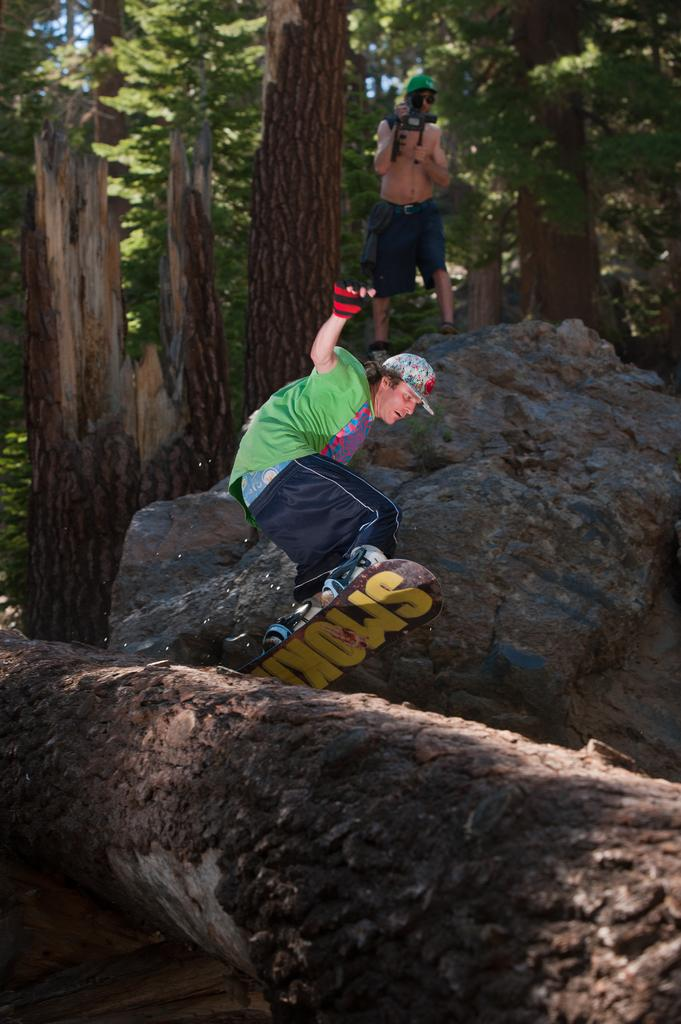What is the main subject of the image? The main subject of the image is a man. What is the man wearing on his head? The man is wearing a cap. What activity is the man engaged in? The man is skating with a skateboard. What can be seen in the background of the image? There are trees and a rock in the background of the image. Can you describe the person in the background holding a camera? There is a person holding a camera with his hands in the background of the image. Can you tell me how many giraffes are in the image? There are no giraffes present in the image. What type of magic is the man performing while skating with a skateboard? There is no magic being performed in the image; the man is simply skating with a skateboard. 